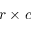Convert formula to latex. <formula><loc_0><loc_0><loc_500><loc_500>r \times c</formula> 